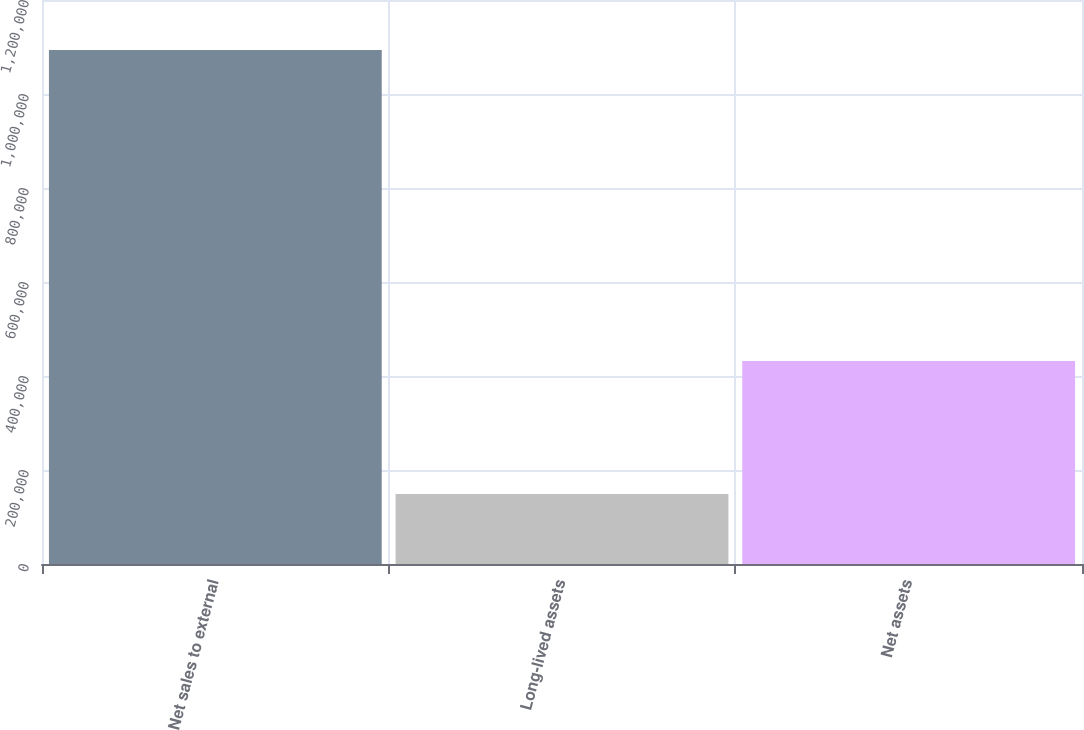<chart> <loc_0><loc_0><loc_500><loc_500><bar_chart><fcel>Net sales to external<fcel>Long-lived assets<fcel>Net assets<nl><fcel>1.09358e+06<fcel>148922<fcel>431795<nl></chart> 